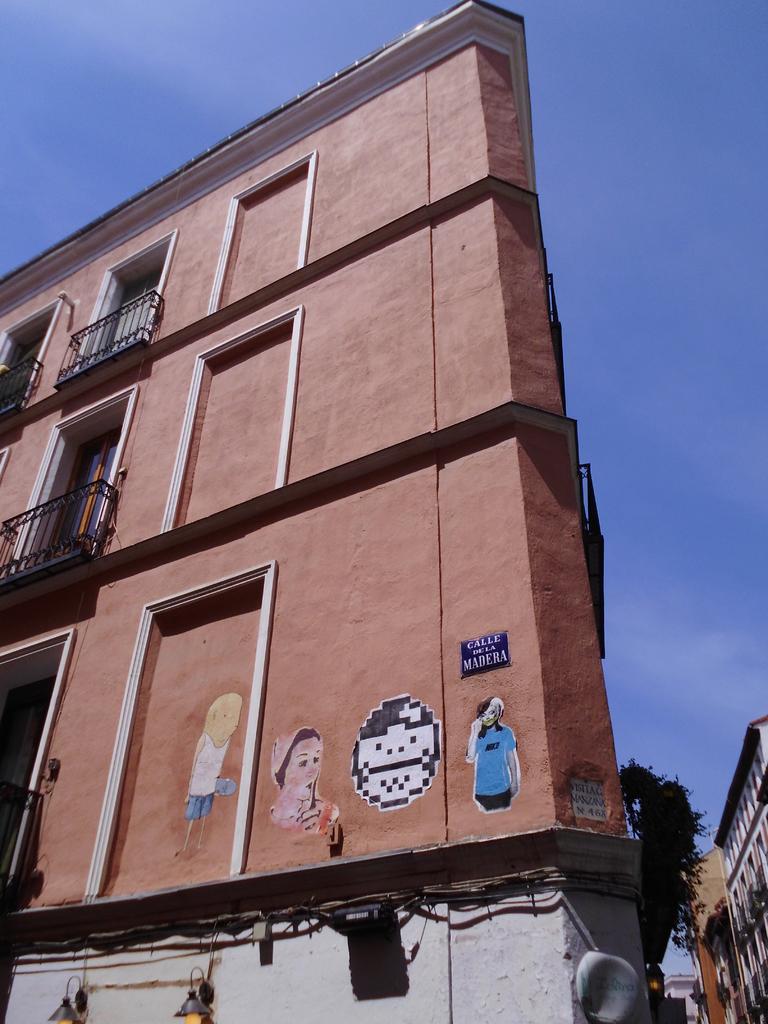Can you describe this image briefly? At the bottom of the image I can see few buildings along with the windows. At the top of the image I can see the sky. 